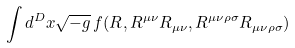Convert formula to latex. <formula><loc_0><loc_0><loc_500><loc_500>\int d ^ { D } x { \sqrt { - g } } \, f ( R , R ^ { \mu \nu } R _ { \mu \nu } , R ^ { \mu \nu \rho \sigma } R _ { \mu \nu \rho \sigma } )</formula> 